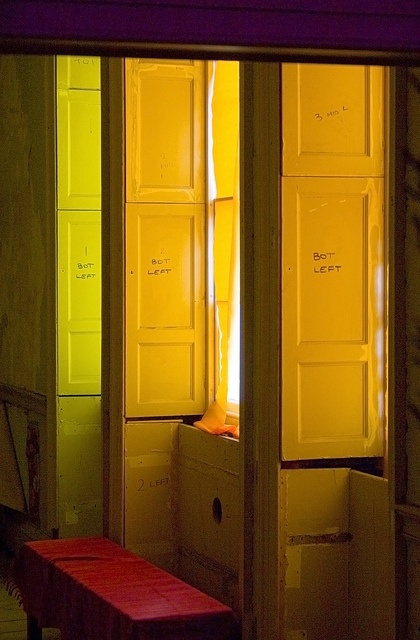Describe the objects in this image and their specific colors. I can see a bench in black, maroon, and brown tones in this image. 